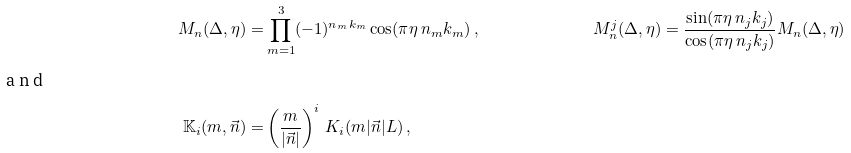Convert formula to latex. <formula><loc_0><loc_0><loc_500><loc_500>M _ { n } ( \Delta , \eta ) = & \prod _ { m = 1 } ^ { 3 } ( - 1 ) ^ { n _ { m } k _ { m } } \cos ( \pi \eta \, n _ { m } k _ { m } ) \, , & & M _ { n } ^ { j } ( \Delta , \eta ) = \frac { \sin ( \pi \eta \, n _ { j } k _ { j } ) } { \cos ( \pi \eta \, n _ { j } k _ { j } ) } M _ { n } ( \Delta , \eta ) \\ \intertext { a n d } \mathbb { K } _ { i } ( m , \vec { n } ) = & \left ( \frac { m } { | \vec { n } | } \right ) ^ { i } \, K _ { i } ( m | \vec { n } | L ) \, ,</formula> 